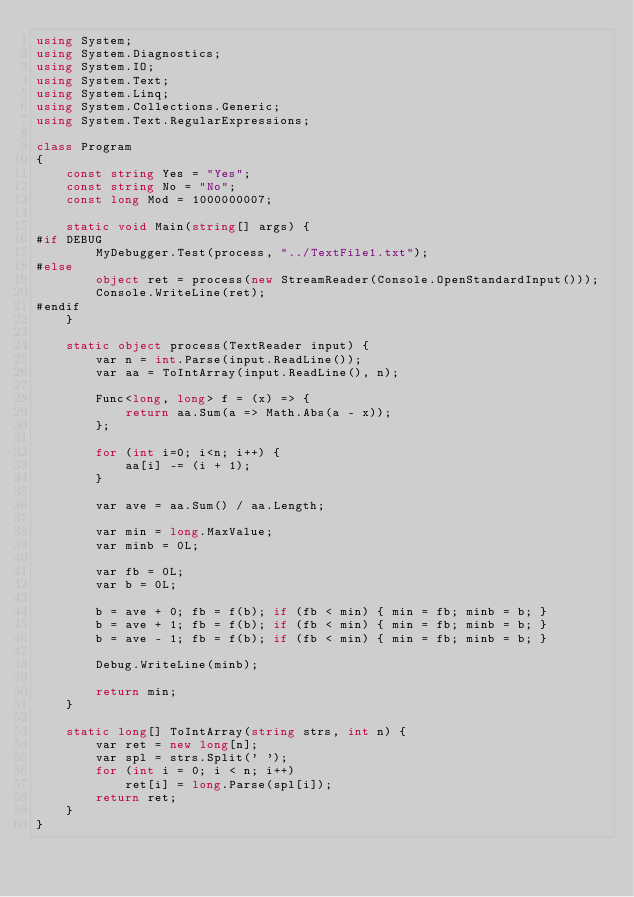Convert code to text. <code><loc_0><loc_0><loc_500><loc_500><_C#_>using System;
using System.Diagnostics;
using System.IO;
using System.Text;
using System.Linq;
using System.Collections.Generic;
using System.Text.RegularExpressions;

class Program
{
    const string Yes = "Yes";
    const string No = "No";
    const long Mod = 1000000007;

    static void Main(string[] args) {
#if DEBUG
        MyDebugger.Test(process, "../TextFile1.txt");
#else
        object ret = process(new StreamReader(Console.OpenStandardInput()));
        Console.WriteLine(ret);
#endif
    }

    static object process(TextReader input) {
        var n = int.Parse(input.ReadLine());
        var aa = ToIntArray(input.ReadLine(), n);

        Func<long, long> f = (x) => {
            return aa.Sum(a => Math.Abs(a - x));
        };

        for (int i=0; i<n; i++) {
            aa[i] -= (i + 1);
        }

        var ave = aa.Sum() / aa.Length;

        var min = long.MaxValue;
        var minb = 0L;

        var fb = 0L;
        var b = 0L;

        b = ave + 0; fb = f(b); if (fb < min) { min = fb; minb = b; }
        b = ave + 1; fb = f(b); if (fb < min) { min = fb; minb = b; }
        b = ave - 1; fb = f(b); if (fb < min) { min = fb; minb = b; }

        Debug.WriteLine(minb);

        return min;
    }

    static long[] ToIntArray(string strs, int n) {
        var ret = new long[n];
        var spl = strs.Split(' ');
        for (int i = 0; i < n; i++)
            ret[i] = long.Parse(spl[i]);
        return ret;
    }
}
</code> 